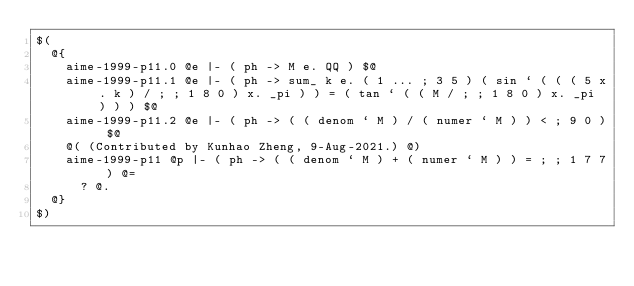Convert code to text. <code><loc_0><loc_0><loc_500><loc_500><_ObjectiveC_>$(
  @{
    aime-1999-p11.0 @e |- ( ph -> M e. QQ ) $@
    aime-1999-p11.1 @e |- ( ph -> sum_ k e. ( 1 ... ; 3 5 ) ( sin ` ( ( ( 5 x. k ) / ; ; 1 8 0 ) x. _pi ) ) = ( tan ` ( ( M / ; ; 1 8 0 ) x. _pi ) ) ) $@
    aime-1999-p11.2 @e |- ( ph -> ( ( denom ` M ) / ( numer ` M ) ) < ; 9 0 ) $@
    @( (Contributed by Kunhao Zheng, 9-Aug-2021.) @)
    aime-1999-p11 @p |- ( ph -> ( ( denom ` M ) + ( numer ` M ) ) = ; ; 1 7 7 ) @=
      ? @.
  @}
$)
</code> 